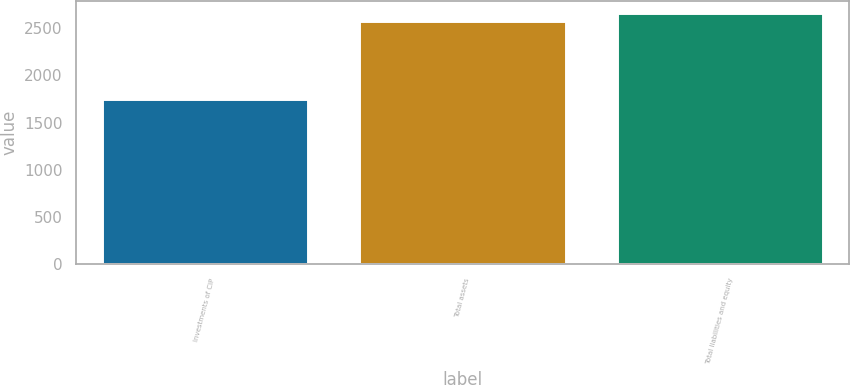Convert chart. <chart><loc_0><loc_0><loc_500><loc_500><bar_chart><fcel>Investments of CIP<fcel>Total assets<fcel>Total liabilities and equity<nl><fcel>1751.4<fcel>2579.2<fcel>2661.98<nl></chart> 